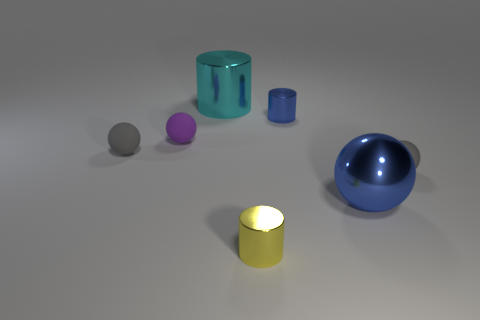Add 2 yellow metal objects. How many objects exist? 9 Subtract all cylinders. How many objects are left? 4 Add 2 large blue metal spheres. How many large blue metal spheres are left? 3 Add 2 big blue metallic cylinders. How many big blue metallic cylinders exist? 2 Subtract 1 yellow cylinders. How many objects are left? 6 Subtract all small blue metal objects. Subtract all gray matte balls. How many objects are left? 4 